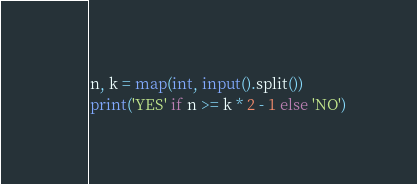<code> <loc_0><loc_0><loc_500><loc_500><_Python_>n, k = map(int, input().split())
print('YES' if n >= k * 2 - 1 else 'NO')
</code> 